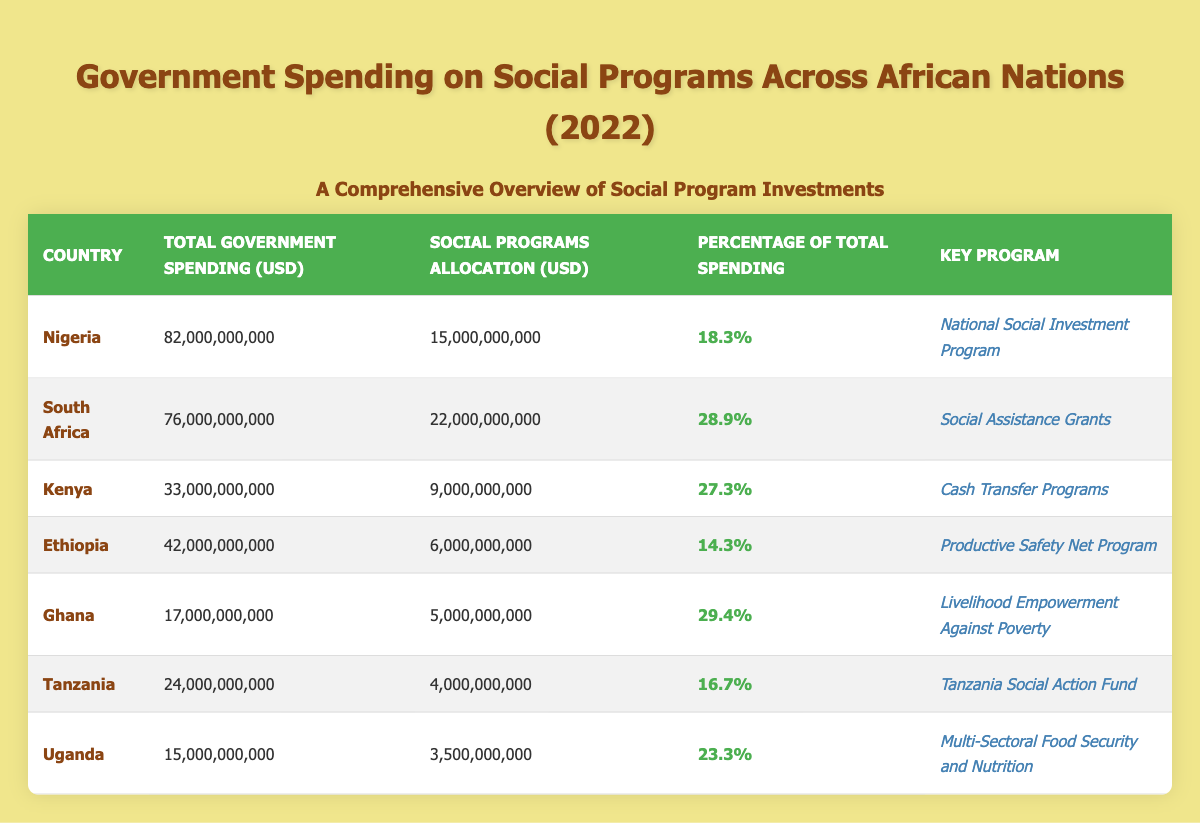What is the total government spending of Nigeria? The table lists Nigeria's total government spending as 82,000,000,000 USD.
Answer: 82,000,000,000 USD Which country allocated the highest percentage of its total spending to social programs? By examining the "Percentage of Total Spending" column, Ghana has the highest allocation at 29.4%.
Answer: Ghana Is the social programs allocation in Uganda less than that in Ethiopia? Uganda's allocation is 3,500,000,000 USD, while Ethiopia's is 6,000,000,000 USD. Since 3,500,000,000 is less than 6,000,000,000, the statement is true.
Answer: Yes What is the average percentage of total spending allocated to social programs across all the countries listed? To find the average, sum the percentages: 18.3 + 28.9 + 27.3 + 14.3 + 29.4 + 16.7 + 23.3 = 138.2. Then divide by the number of countries (7): 138.2 / 7 = 19.74.
Answer: 19.74% Did Kenya spend less than 10 billion USD on social programs? The table shows Kenya's social programs allocation is 9,000,000,000 USD, which is indeed less than 10 billion USD.
Answer: Yes What is the difference in social programs allocation between South Africa and Tanzania? South Africa allocated 22,000,000,000 USD, while Tanzania allocated 4,000,000,000 USD. The difference is 22,000,000,000 - 4,000,000,000 = 18,000,000,000 USD.
Answer: 18,000,000,000 USD Which country has the key program "Multi-Sectoral Food Security and Nutrition"? Referring to the "Key Program" column, Uganda is identified as having this program.
Answer: Uganda What is the total social programs allocation for Nigeria and Ghana combined? Nigeria's allocation is 15,000,000,000 USD and Ghana's is 5,000,000,000 USD. Adding these gives: 15,000,000,000 + 5,000,000,000 = 20,000,000,000 USD.
Answer: 20,000,000,000 USD 